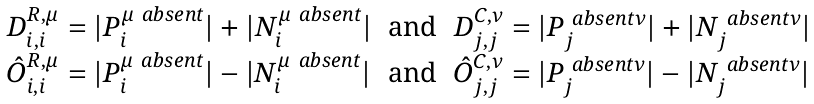<formula> <loc_0><loc_0><loc_500><loc_500>\begin{array} { c c c } D ^ { R , \mu } _ { i , i } = | P ^ { \mu \ a b s e n t } _ { i } | + | N ^ { \mu \ a b s e n t } _ { i } | & \text {and} & D ^ { C , \nu } _ { j , j } = | P ^ { \ a b s e n t \nu } _ { j } | + | N ^ { \ a b s e n t \nu } _ { j } | \\ \hat { O } ^ { R , \mu } _ { i , i } = | P ^ { \mu \ a b s e n t } _ { i } | - | N ^ { \mu \ a b s e n t } _ { i } | & \text {and} & \hat { O } ^ { C , \nu } _ { j , j } = | P ^ { \ a b s e n t \nu } _ { j } | - | N ^ { \ a b s e n t \nu } _ { j } | \\ \end{array}</formula> 